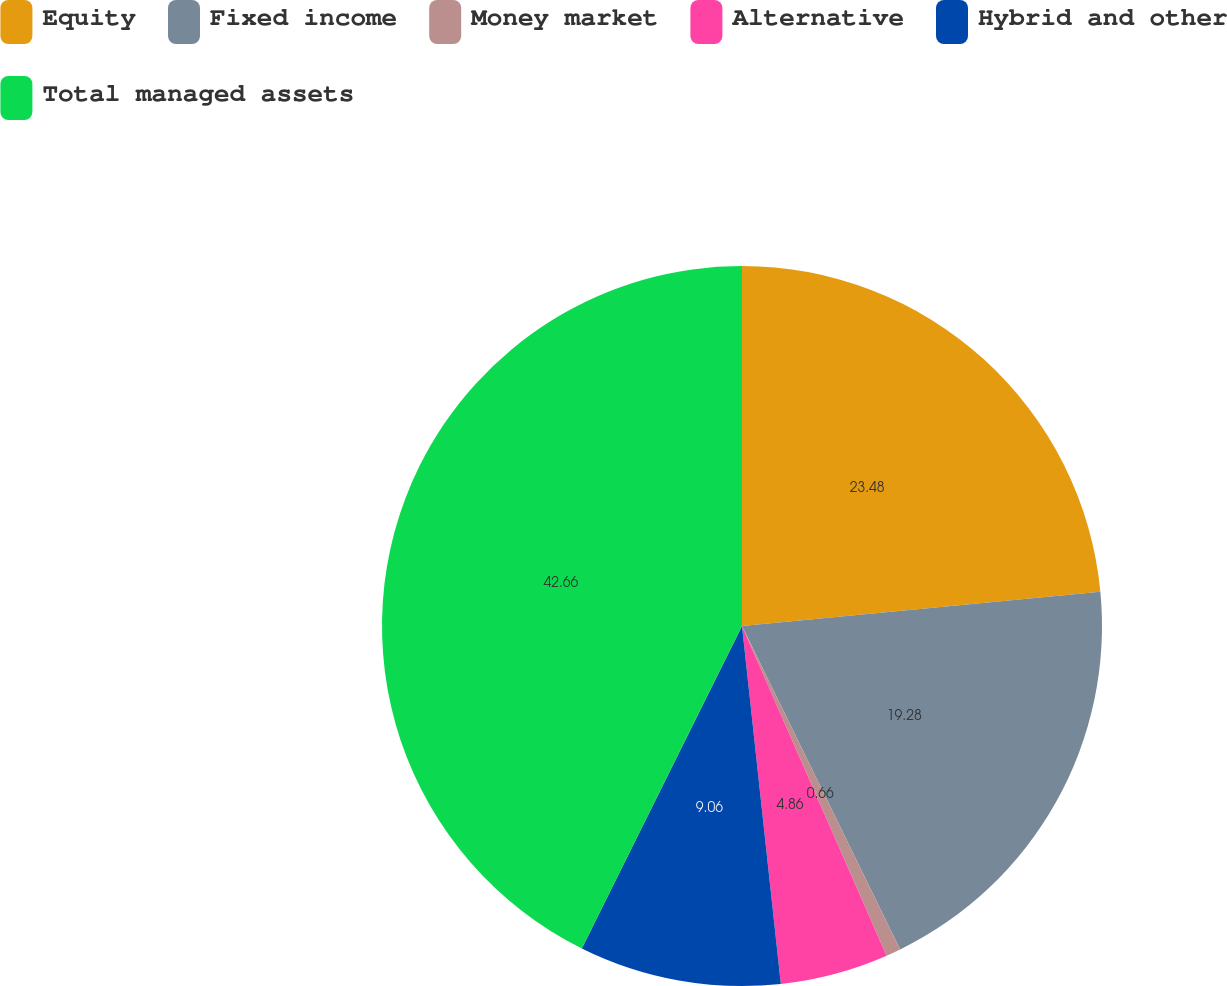Convert chart. <chart><loc_0><loc_0><loc_500><loc_500><pie_chart><fcel>Equity<fcel>Fixed income<fcel>Money market<fcel>Alternative<fcel>Hybrid and other<fcel>Total managed assets<nl><fcel>23.48%<fcel>19.28%<fcel>0.66%<fcel>4.86%<fcel>9.06%<fcel>42.66%<nl></chart> 